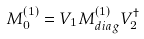<formula> <loc_0><loc_0><loc_500><loc_500>M _ { 0 } ^ { \left ( 1 \right ) } = V _ { 1 } M _ { d i a g } ^ { \left ( 1 \right ) } V _ { 2 } ^ { \dagger }</formula> 